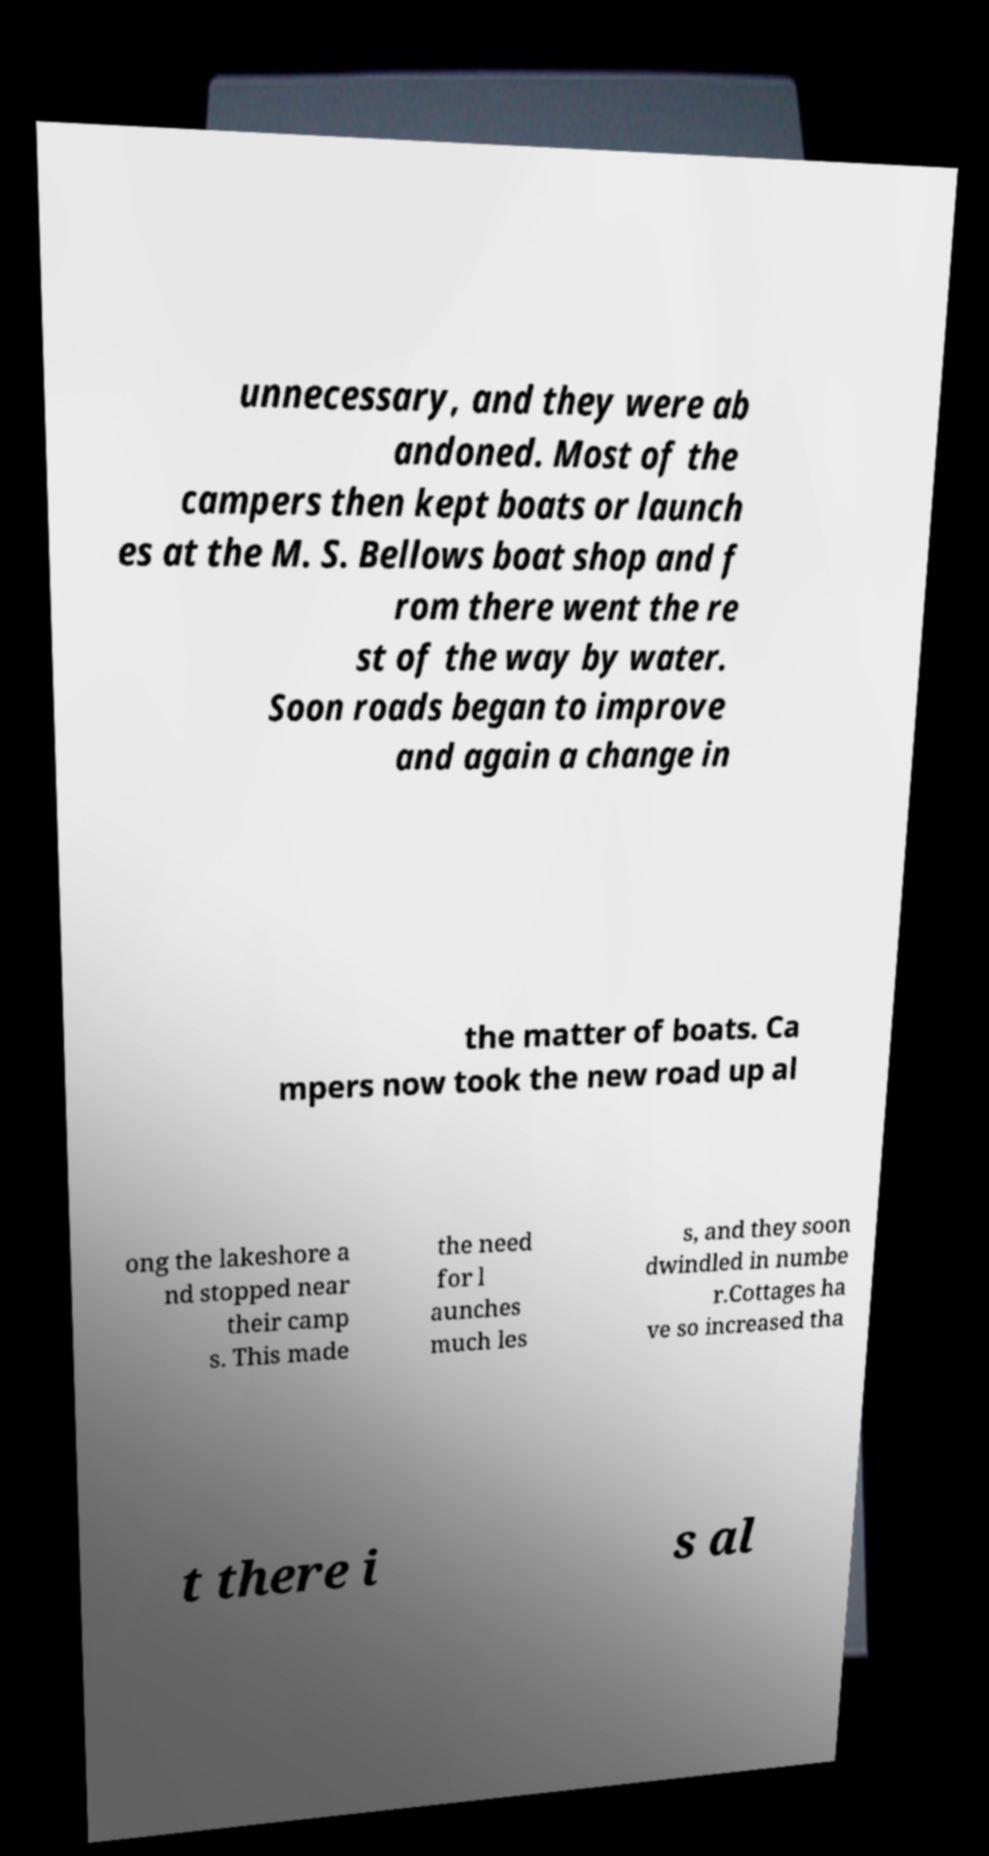Can you accurately transcribe the text from the provided image for me? unnecessary, and they were ab andoned. Most of the campers then kept boats or launch es at the M. S. Bellows boat shop and f rom there went the re st of the way by water. Soon roads began to improve and again a change in the matter of boats. Ca mpers now took the new road up al ong the lakeshore a nd stopped near their camp s. This made the need for l aunches much les s, and they soon dwindled in numbe r.Cottages ha ve so increased tha t there i s al 